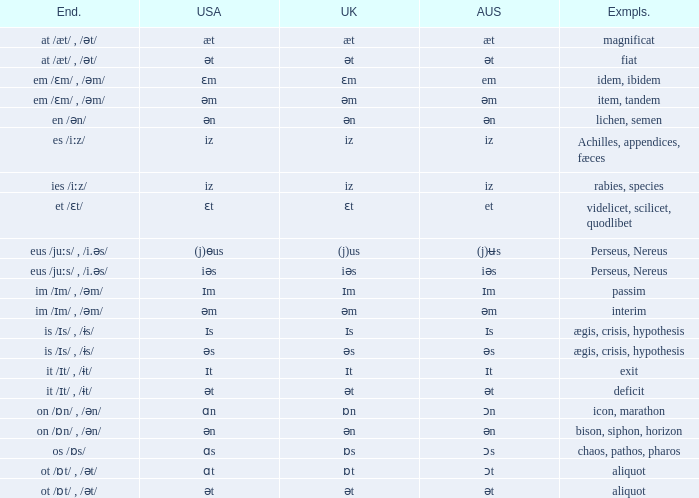Which British has Examples of exit? Ɪt. 